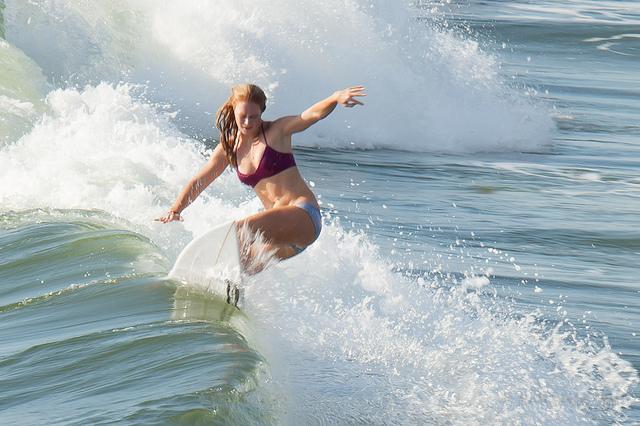What is the woman doing?
Answer briefly. Surfing. What color is the women's surfboard?
Answer briefly. White. Is the woman wearing a one or two piece swimsuit?
Give a very brief answer. 2. 